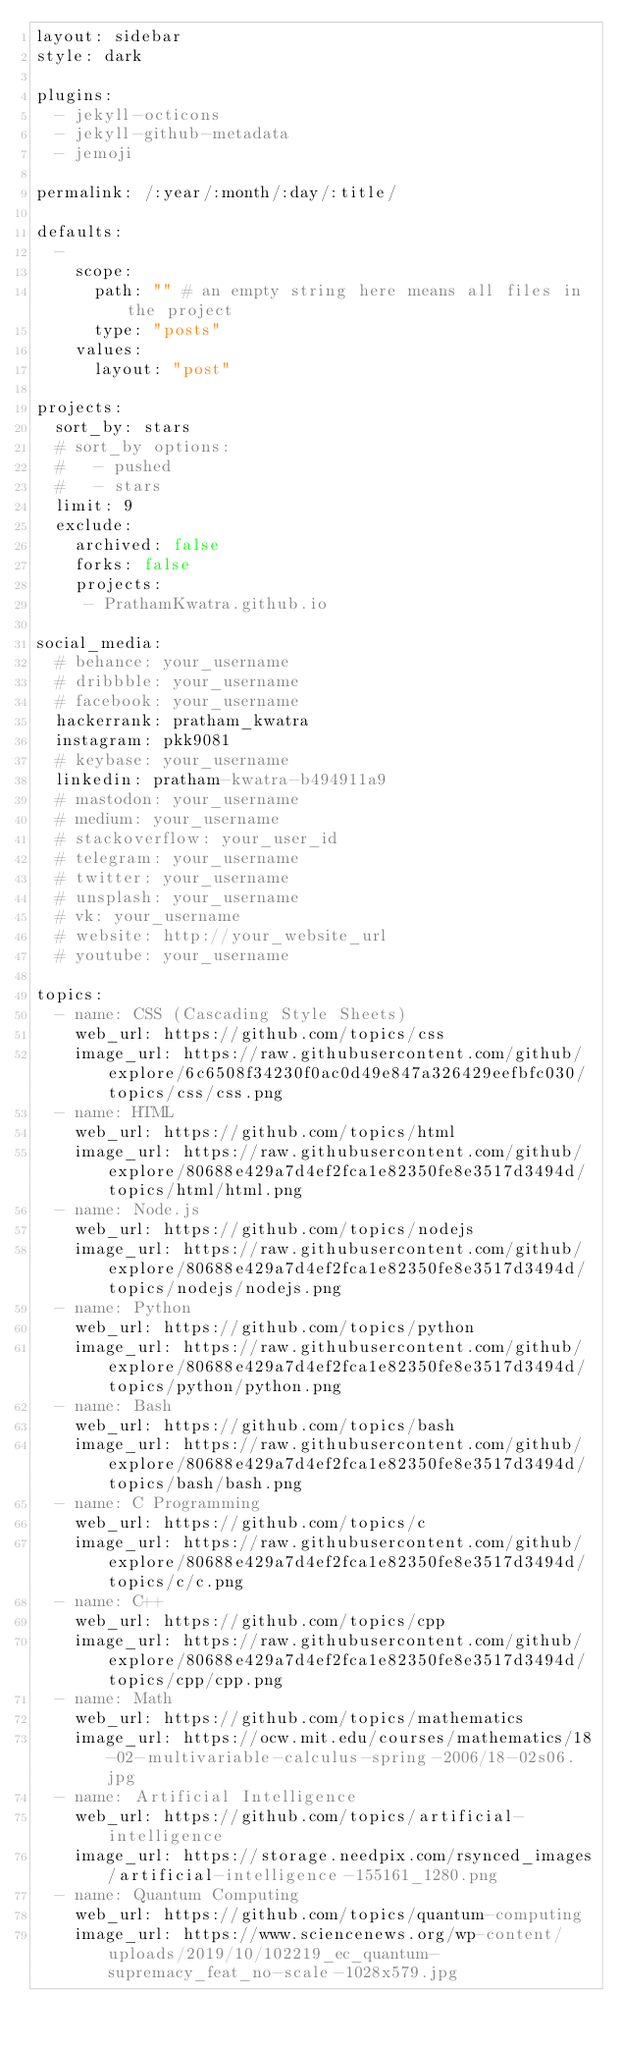<code> <loc_0><loc_0><loc_500><loc_500><_YAML_>layout: sidebar
style: dark

plugins:
  - jekyll-octicons
  - jekyll-github-metadata
  - jemoji

permalink: /:year/:month/:day/:title/

defaults:
  -
    scope:
      path: "" # an empty string here means all files in the project
      type: "posts"
    values:
      layout: "post"

projects:
  sort_by: stars
  # sort_by options:
  #   - pushed
  #   - stars
  limit: 9
  exclude:
    archived: false
    forks: false
    projects:
     - PrathamKwatra.github.io

social_media:
  # behance: your_username
  # dribbble: your_username
  # facebook: your_username
  hackerrank: pratham_kwatra
  instagram: pkk9081
  # keybase: your_username
  linkedin: pratham-kwatra-b494911a9
  # mastodon: your_username
  # medium: your_username
  # stackoverflow: your_user_id
  # telegram: your_username
  # twitter: your_username
  # unsplash: your_username
  # vk: your_username
  # website: http://your_website_url
  # youtube: your_username

topics:
  - name: CSS (Cascading Style Sheets)
    web_url: https://github.com/topics/css
    image_url: https://raw.githubusercontent.com/github/explore/6c6508f34230f0ac0d49e847a326429eefbfc030/topics/css/css.png
  - name: HTML
    web_url: https://github.com/topics/html
    image_url: https://raw.githubusercontent.com/github/explore/80688e429a7d4ef2fca1e82350fe8e3517d3494d/topics/html/html.png
  - name: Node.js
    web_url: https://github.com/topics/nodejs
    image_url: https://raw.githubusercontent.com/github/explore/80688e429a7d4ef2fca1e82350fe8e3517d3494d/topics/nodejs/nodejs.png
  - name: Python
    web_url: https://github.com/topics/python
    image_url: https://raw.githubusercontent.com/github/explore/80688e429a7d4ef2fca1e82350fe8e3517d3494d/topics/python/python.png
  - name: Bash
    web_url: https://github.com/topics/bash
    image_url: https://raw.githubusercontent.com/github/explore/80688e429a7d4ef2fca1e82350fe8e3517d3494d/topics/bash/bash.png
  - name: C Programming
    web_url: https://github.com/topics/c
    image_url: https://raw.githubusercontent.com/github/explore/80688e429a7d4ef2fca1e82350fe8e3517d3494d/topics/c/c.png
  - name: C++
    web_url: https://github.com/topics/cpp
    image_url: https://raw.githubusercontent.com/github/explore/80688e429a7d4ef2fca1e82350fe8e3517d3494d/topics/cpp/cpp.png
  - name: Math
    web_url: https://github.com/topics/mathematics
    image_url: https://ocw.mit.edu/courses/mathematics/18-02-multivariable-calculus-spring-2006/18-02s06.jpg
  - name: Artificial Intelligence
    web_url: https://github.com/topics/artificial-intelligence
    image_url: https://storage.needpix.com/rsynced_images/artificial-intelligence-155161_1280.png
  - name: Quantum Computing
    web_url: https://github.com/topics/quantum-computing
    image_url: https://www.sciencenews.org/wp-content/uploads/2019/10/102219_ec_quantum-supremacy_feat_no-scale-1028x579.jpg
</code> 